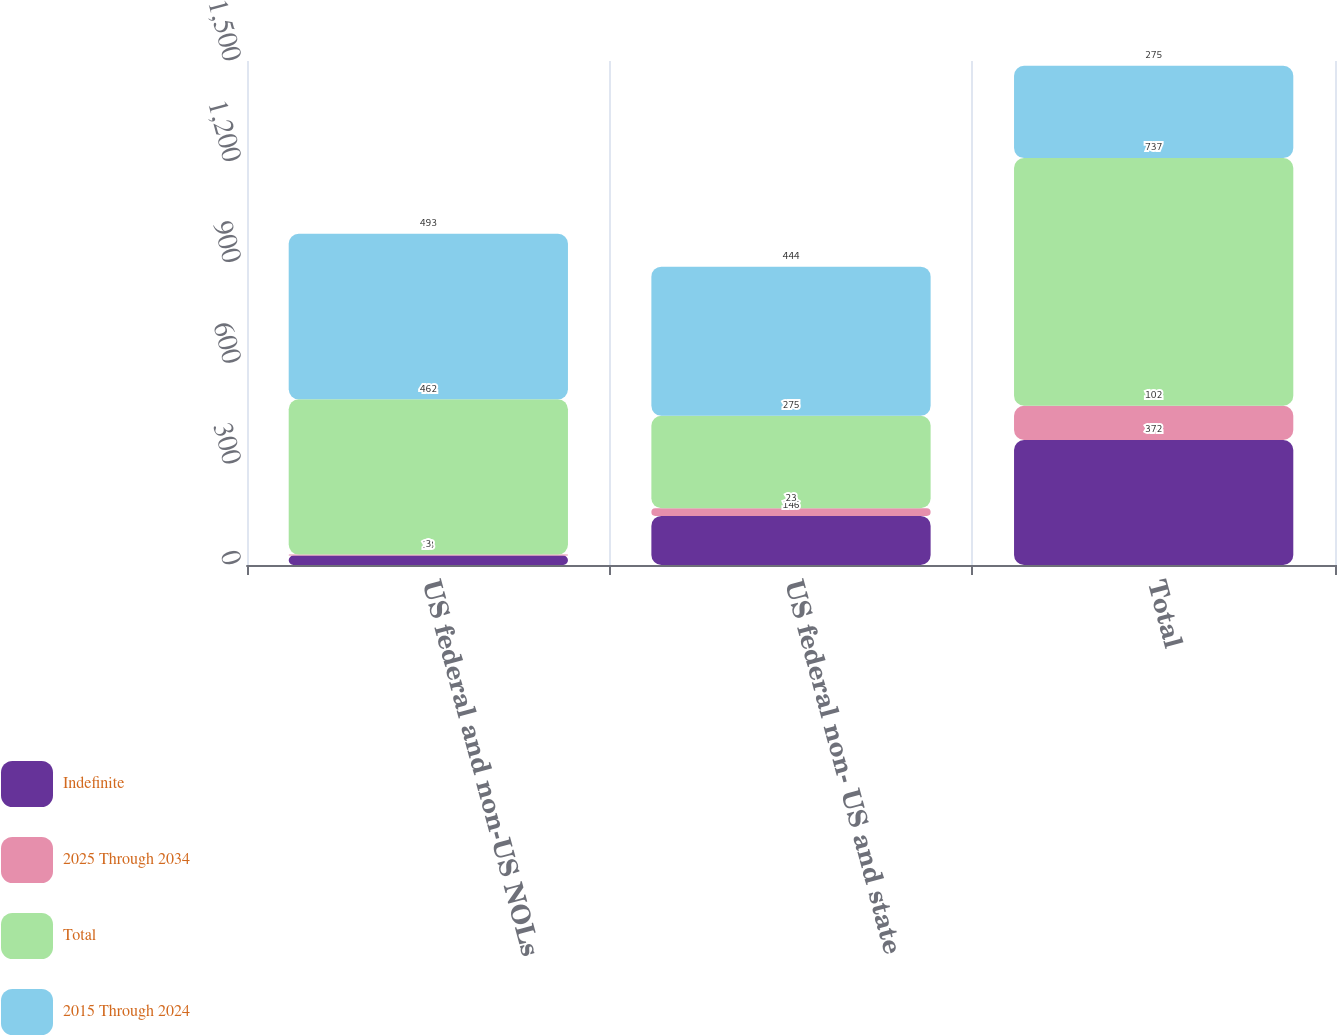Convert chart. <chart><loc_0><loc_0><loc_500><loc_500><stacked_bar_chart><ecel><fcel>US federal and non-US NOLs<fcel>US federal non- US and state<fcel>Total<nl><fcel>Indefinite<fcel>28<fcel>146<fcel>372<nl><fcel>2025 Through 2034<fcel>3<fcel>23<fcel>102<nl><fcel>Total<fcel>462<fcel>275<fcel>737<nl><fcel>2015 Through 2024<fcel>493<fcel>444<fcel>275<nl></chart> 